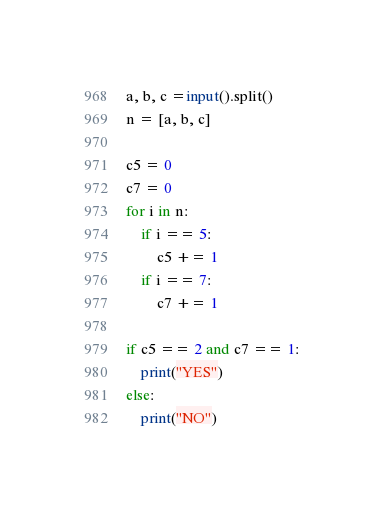Convert code to text. <code><loc_0><loc_0><loc_500><loc_500><_Python_>a, b, c =input().split()
n = [a, b, c]

c5 = 0
c7 = 0
for i in n:
    if i == 5:
        c5 += 1
    if i == 7:
        c7 += 1

if c5 == 2 and c7 == 1:
    print("YES")
else:
    print("NO")
</code> 